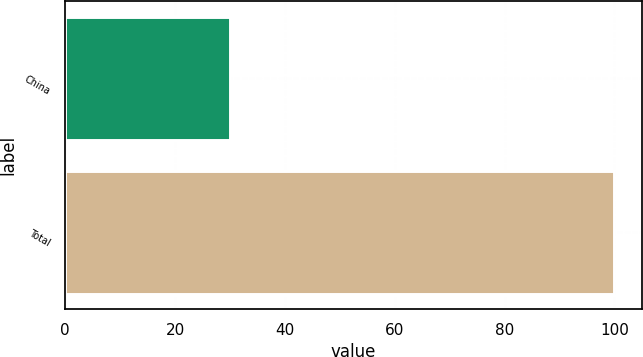Convert chart to OTSL. <chart><loc_0><loc_0><loc_500><loc_500><bar_chart><fcel>China<fcel>Total<nl><fcel>30<fcel>100<nl></chart> 